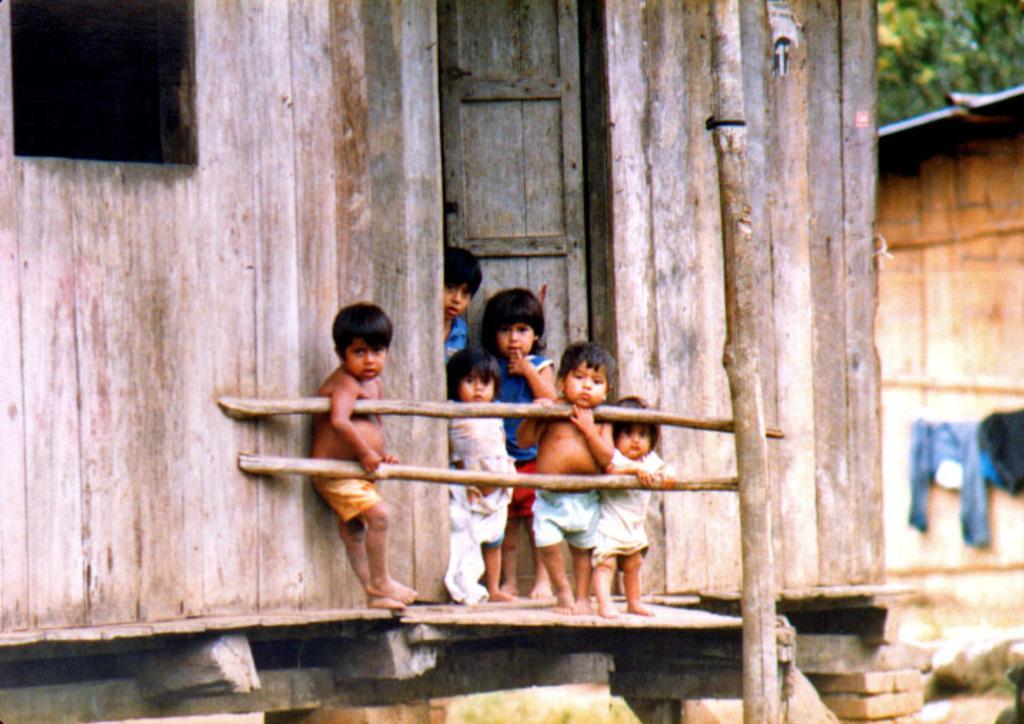Describe this image in one or two sentences. Here in this picture we can see number of children present on a wooden board and in front of them we can see a wooden railing and behind them we can see a house and we can see a window and a door also present over there and on the right side we can see some clothes hanging on a wire and we can also see trees present over there. 